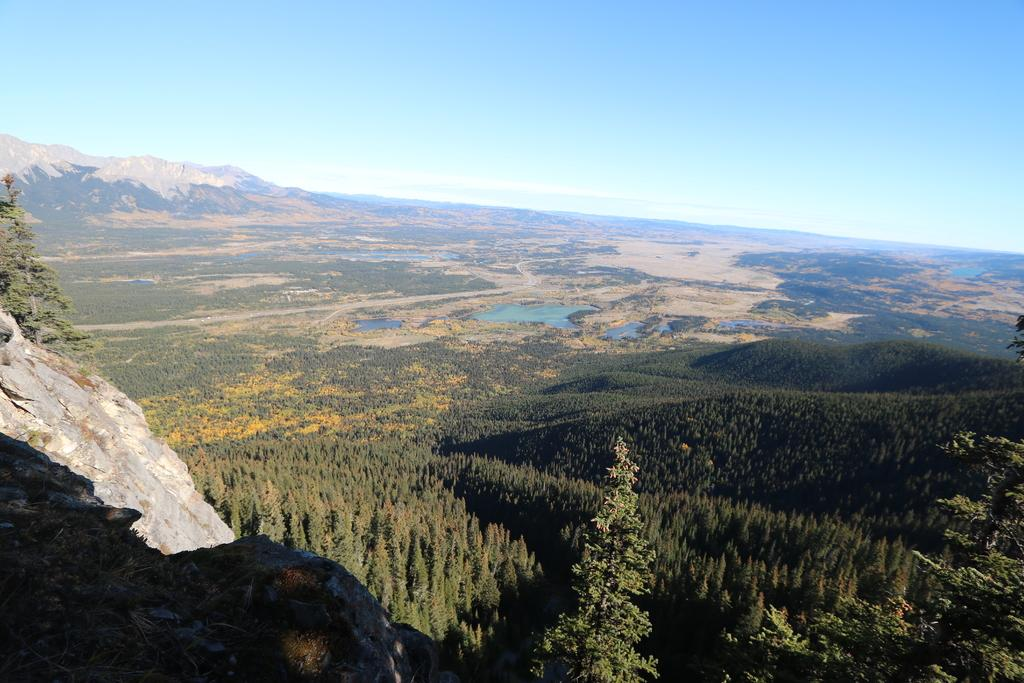What type of landscape is depicted in the image? The image contains an outside view of mountains. Are there any plants visible in the image? Yes, there is a group of trees in the image. What part of the natural environment can be seen in the image? The sky is visible in the image. What type of shock can be seen affecting the mountains in the image? There is no shock present in the image; it is a static view of the mountains. Do the bushes in the image have any special existence? There are no bushes mentioned in the image; only mountains and a group of trees are present. 